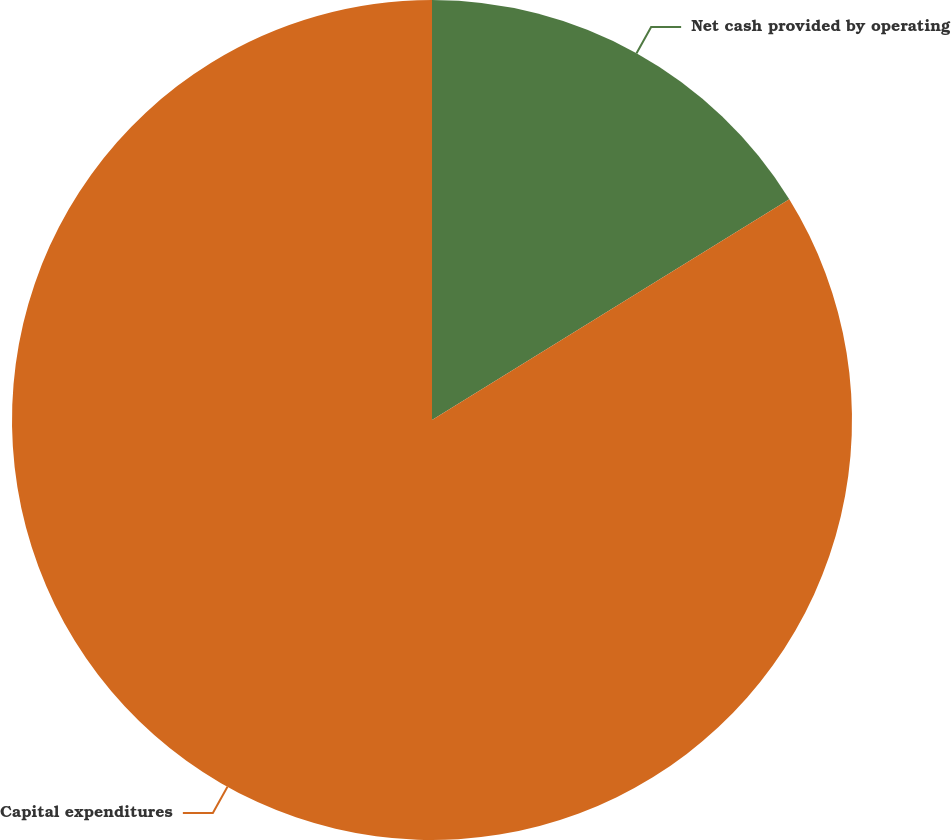Convert chart. <chart><loc_0><loc_0><loc_500><loc_500><pie_chart><fcel>Net cash provided by operating<fcel>Capital expenditures<nl><fcel>16.19%<fcel>83.81%<nl></chart> 